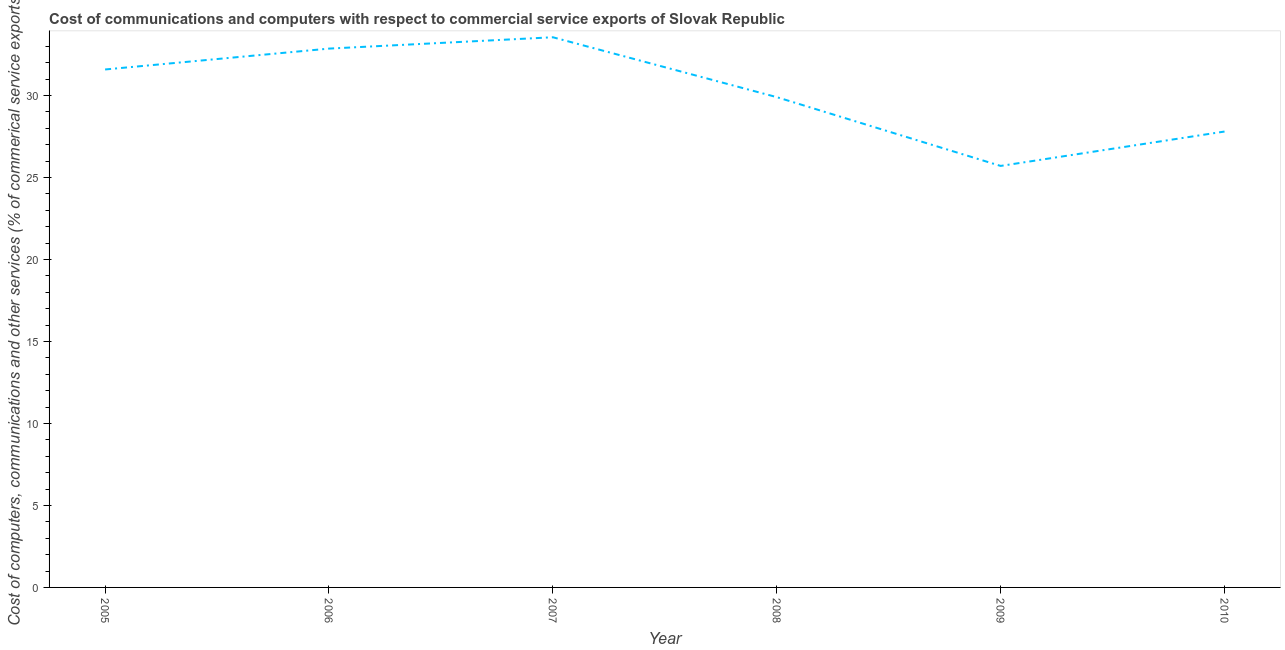What is the cost of communications in 2006?
Your answer should be very brief. 32.86. Across all years, what is the maximum cost of communications?
Keep it short and to the point. 33.55. Across all years, what is the minimum cost of communications?
Your answer should be compact. 25.71. In which year was the  computer and other services maximum?
Provide a short and direct response. 2007. In which year was the cost of communications minimum?
Your answer should be compact. 2009. What is the sum of the cost of communications?
Make the answer very short. 181.41. What is the difference between the cost of communications in 2006 and 2009?
Your answer should be compact. 7.15. What is the average  computer and other services per year?
Your answer should be very brief. 30.23. What is the median  computer and other services?
Offer a terse response. 30.74. In how many years, is the  computer and other services greater than 7 %?
Your response must be concise. 6. Do a majority of the years between 2005 and 2008 (inclusive) have  computer and other services greater than 12 %?
Your response must be concise. Yes. What is the ratio of the cost of communications in 2005 to that in 2010?
Offer a very short reply. 1.14. Is the  computer and other services in 2006 less than that in 2008?
Make the answer very short. No. Is the difference between the  computer and other services in 2005 and 2007 greater than the difference between any two years?
Offer a very short reply. No. What is the difference between the highest and the second highest cost of communications?
Give a very brief answer. 0.69. What is the difference between the highest and the lowest  computer and other services?
Your response must be concise. 7.85. How many years are there in the graph?
Provide a short and direct response. 6. What is the difference between two consecutive major ticks on the Y-axis?
Ensure brevity in your answer.  5. What is the title of the graph?
Make the answer very short. Cost of communications and computers with respect to commercial service exports of Slovak Republic. What is the label or title of the Y-axis?
Provide a short and direct response. Cost of computers, communications and other services (% of commerical service exports). What is the Cost of computers, communications and other services (% of commerical service exports) in 2005?
Offer a terse response. 31.59. What is the Cost of computers, communications and other services (% of commerical service exports) of 2006?
Keep it short and to the point. 32.86. What is the Cost of computers, communications and other services (% of commerical service exports) in 2007?
Offer a very short reply. 33.55. What is the Cost of computers, communications and other services (% of commerical service exports) in 2008?
Ensure brevity in your answer.  29.9. What is the Cost of computers, communications and other services (% of commerical service exports) of 2009?
Give a very brief answer. 25.71. What is the Cost of computers, communications and other services (% of commerical service exports) of 2010?
Your response must be concise. 27.8. What is the difference between the Cost of computers, communications and other services (% of commerical service exports) in 2005 and 2006?
Provide a succinct answer. -1.27. What is the difference between the Cost of computers, communications and other services (% of commerical service exports) in 2005 and 2007?
Offer a very short reply. -1.96. What is the difference between the Cost of computers, communications and other services (% of commerical service exports) in 2005 and 2008?
Ensure brevity in your answer.  1.69. What is the difference between the Cost of computers, communications and other services (% of commerical service exports) in 2005 and 2009?
Offer a terse response. 5.88. What is the difference between the Cost of computers, communications and other services (% of commerical service exports) in 2005 and 2010?
Your answer should be compact. 3.78. What is the difference between the Cost of computers, communications and other services (% of commerical service exports) in 2006 and 2007?
Your answer should be very brief. -0.69. What is the difference between the Cost of computers, communications and other services (% of commerical service exports) in 2006 and 2008?
Offer a terse response. 2.96. What is the difference between the Cost of computers, communications and other services (% of commerical service exports) in 2006 and 2009?
Keep it short and to the point. 7.15. What is the difference between the Cost of computers, communications and other services (% of commerical service exports) in 2006 and 2010?
Ensure brevity in your answer.  5.06. What is the difference between the Cost of computers, communications and other services (% of commerical service exports) in 2007 and 2008?
Offer a very short reply. 3.65. What is the difference between the Cost of computers, communications and other services (% of commerical service exports) in 2007 and 2009?
Your answer should be very brief. 7.85. What is the difference between the Cost of computers, communications and other services (% of commerical service exports) in 2007 and 2010?
Offer a terse response. 5.75. What is the difference between the Cost of computers, communications and other services (% of commerical service exports) in 2008 and 2009?
Your response must be concise. 4.19. What is the difference between the Cost of computers, communications and other services (% of commerical service exports) in 2008 and 2010?
Keep it short and to the point. 2.1. What is the difference between the Cost of computers, communications and other services (% of commerical service exports) in 2009 and 2010?
Your response must be concise. -2.1. What is the ratio of the Cost of computers, communications and other services (% of commerical service exports) in 2005 to that in 2007?
Your answer should be compact. 0.94. What is the ratio of the Cost of computers, communications and other services (% of commerical service exports) in 2005 to that in 2008?
Make the answer very short. 1.06. What is the ratio of the Cost of computers, communications and other services (% of commerical service exports) in 2005 to that in 2009?
Your response must be concise. 1.23. What is the ratio of the Cost of computers, communications and other services (% of commerical service exports) in 2005 to that in 2010?
Your response must be concise. 1.14. What is the ratio of the Cost of computers, communications and other services (% of commerical service exports) in 2006 to that in 2007?
Your answer should be very brief. 0.98. What is the ratio of the Cost of computers, communications and other services (% of commerical service exports) in 2006 to that in 2008?
Offer a very short reply. 1.1. What is the ratio of the Cost of computers, communications and other services (% of commerical service exports) in 2006 to that in 2009?
Offer a very short reply. 1.28. What is the ratio of the Cost of computers, communications and other services (% of commerical service exports) in 2006 to that in 2010?
Your response must be concise. 1.18. What is the ratio of the Cost of computers, communications and other services (% of commerical service exports) in 2007 to that in 2008?
Ensure brevity in your answer.  1.12. What is the ratio of the Cost of computers, communications and other services (% of commerical service exports) in 2007 to that in 2009?
Offer a terse response. 1.3. What is the ratio of the Cost of computers, communications and other services (% of commerical service exports) in 2007 to that in 2010?
Ensure brevity in your answer.  1.21. What is the ratio of the Cost of computers, communications and other services (% of commerical service exports) in 2008 to that in 2009?
Offer a terse response. 1.16. What is the ratio of the Cost of computers, communications and other services (% of commerical service exports) in 2008 to that in 2010?
Offer a very short reply. 1.07. What is the ratio of the Cost of computers, communications and other services (% of commerical service exports) in 2009 to that in 2010?
Your answer should be very brief. 0.93. 